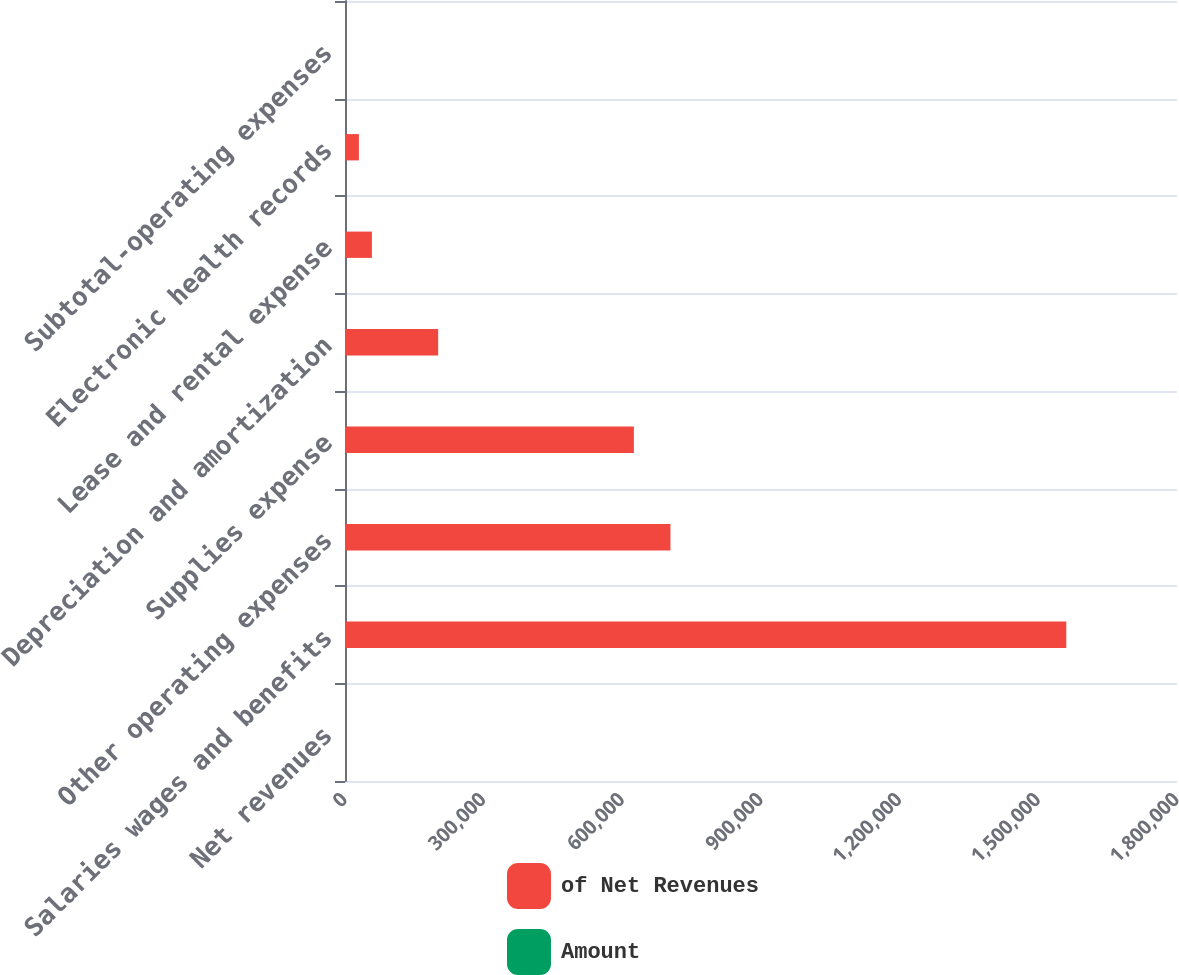Convert chart to OTSL. <chart><loc_0><loc_0><loc_500><loc_500><stacked_bar_chart><ecel><fcel>Net revenues<fcel>Salaries wages and benefits<fcel>Other operating expenses<fcel>Supplies expense<fcel>Depreciation and amortization<fcel>Lease and rental expense<fcel>Electronic health records<fcel>Subtotal-operating expenses<nl><fcel>of Net Revenues<fcel>95.05<fcel>1.56047e+06<fcel>704108<fcel>624955<fcel>201536<fcel>58187<fcel>30038<fcel>95.05<nl><fcel>Amount<fcel>100<fcel>45.1<fcel>20.3<fcel>18.1<fcel>5.8<fcel>1.7<fcel>0.9<fcel>90.1<nl></chart> 